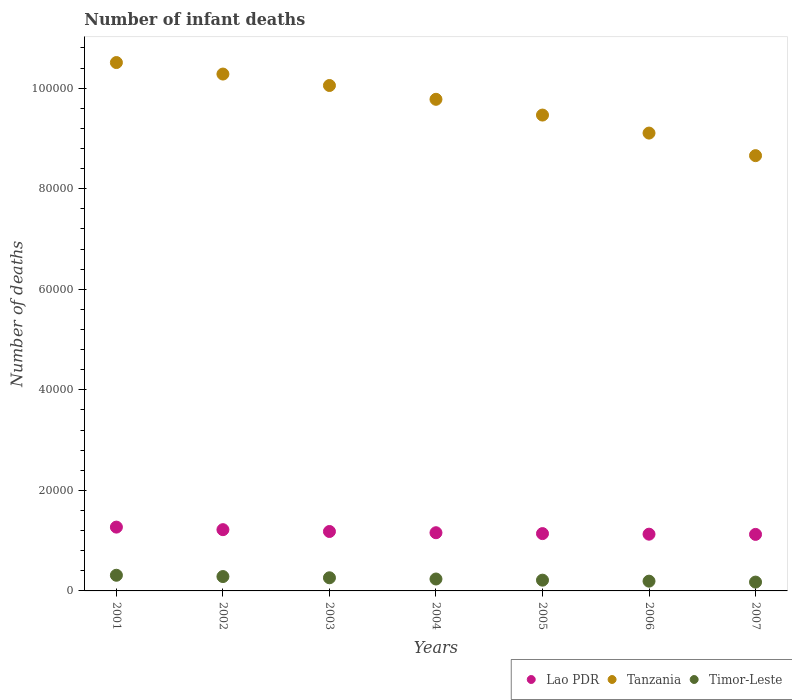What is the number of infant deaths in Timor-Leste in 2001?
Provide a short and direct response. 3116. Across all years, what is the maximum number of infant deaths in Timor-Leste?
Your response must be concise. 3116. Across all years, what is the minimum number of infant deaths in Timor-Leste?
Provide a short and direct response. 1757. What is the total number of infant deaths in Lao PDR in the graph?
Provide a short and direct response. 8.22e+04. What is the difference between the number of infant deaths in Timor-Leste in 2004 and that in 2006?
Give a very brief answer. 427. What is the difference between the number of infant deaths in Timor-Leste in 2003 and the number of infant deaths in Lao PDR in 2005?
Your response must be concise. -8790. What is the average number of infant deaths in Tanzania per year?
Keep it short and to the point. 9.69e+04. In the year 2002, what is the difference between the number of infant deaths in Lao PDR and number of infant deaths in Tanzania?
Give a very brief answer. -9.06e+04. What is the ratio of the number of infant deaths in Timor-Leste in 2002 to that in 2006?
Offer a terse response. 1.47. Is the number of infant deaths in Tanzania in 2002 less than that in 2005?
Offer a very short reply. No. What is the difference between the highest and the second highest number of infant deaths in Timor-Leste?
Keep it short and to the point. 259. What is the difference between the highest and the lowest number of infant deaths in Tanzania?
Ensure brevity in your answer.  1.85e+04. How many years are there in the graph?
Your answer should be very brief. 7. Are the values on the major ticks of Y-axis written in scientific E-notation?
Offer a terse response. No. Does the graph contain any zero values?
Make the answer very short. No. Does the graph contain grids?
Give a very brief answer. No. Where does the legend appear in the graph?
Your answer should be very brief. Bottom right. What is the title of the graph?
Your response must be concise. Number of infant deaths. What is the label or title of the X-axis?
Give a very brief answer. Years. What is the label or title of the Y-axis?
Offer a terse response. Number of deaths. What is the Number of deaths in Lao PDR in 2001?
Offer a very short reply. 1.27e+04. What is the Number of deaths of Tanzania in 2001?
Your answer should be very brief. 1.05e+05. What is the Number of deaths of Timor-Leste in 2001?
Give a very brief answer. 3116. What is the Number of deaths in Lao PDR in 2002?
Provide a short and direct response. 1.22e+04. What is the Number of deaths in Tanzania in 2002?
Ensure brevity in your answer.  1.03e+05. What is the Number of deaths of Timor-Leste in 2002?
Your response must be concise. 2857. What is the Number of deaths in Lao PDR in 2003?
Make the answer very short. 1.18e+04. What is the Number of deaths in Tanzania in 2003?
Your answer should be compact. 1.01e+05. What is the Number of deaths of Timor-Leste in 2003?
Your response must be concise. 2612. What is the Number of deaths in Lao PDR in 2004?
Your answer should be compact. 1.16e+04. What is the Number of deaths of Tanzania in 2004?
Give a very brief answer. 9.78e+04. What is the Number of deaths of Timor-Leste in 2004?
Keep it short and to the point. 2369. What is the Number of deaths of Lao PDR in 2005?
Offer a terse response. 1.14e+04. What is the Number of deaths in Tanzania in 2005?
Offer a terse response. 9.46e+04. What is the Number of deaths of Timor-Leste in 2005?
Your answer should be very brief. 2140. What is the Number of deaths of Lao PDR in 2006?
Your response must be concise. 1.13e+04. What is the Number of deaths of Tanzania in 2006?
Provide a short and direct response. 9.11e+04. What is the Number of deaths in Timor-Leste in 2006?
Offer a very short reply. 1942. What is the Number of deaths of Lao PDR in 2007?
Your answer should be compact. 1.12e+04. What is the Number of deaths of Tanzania in 2007?
Ensure brevity in your answer.  8.66e+04. What is the Number of deaths of Timor-Leste in 2007?
Your answer should be compact. 1757. Across all years, what is the maximum Number of deaths in Lao PDR?
Ensure brevity in your answer.  1.27e+04. Across all years, what is the maximum Number of deaths in Tanzania?
Offer a terse response. 1.05e+05. Across all years, what is the maximum Number of deaths in Timor-Leste?
Your answer should be compact. 3116. Across all years, what is the minimum Number of deaths of Lao PDR?
Ensure brevity in your answer.  1.12e+04. Across all years, what is the minimum Number of deaths of Tanzania?
Your response must be concise. 8.66e+04. Across all years, what is the minimum Number of deaths in Timor-Leste?
Offer a terse response. 1757. What is the total Number of deaths in Lao PDR in the graph?
Ensure brevity in your answer.  8.22e+04. What is the total Number of deaths in Tanzania in the graph?
Your response must be concise. 6.79e+05. What is the total Number of deaths in Timor-Leste in the graph?
Offer a very short reply. 1.68e+04. What is the difference between the Number of deaths in Lao PDR in 2001 and that in 2002?
Your answer should be very brief. 508. What is the difference between the Number of deaths in Tanzania in 2001 and that in 2002?
Provide a short and direct response. 2289. What is the difference between the Number of deaths in Timor-Leste in 2001 and that in 2002?
Your answer should be compact. 259. What is the difference between the Number of deaths in Lao PDR in 2001 and that in 2003?
Make the answer very short. 871. What is the difference between the Number of deaths of Tanzania in 2001 and that in 2003?
Offer a very short reply. 4564. What is the difference between the Number of deaths of Timor-Leste in 2001 and that in 2003?
Your answer should be very brief. 504. What is the difference between the Number of deaths of Lao PDR in 2001 and that in 2004?
Provide a succinct answer. 1116. What is the difference between the Number of deaths of Tanzania in 2001 and that in 2004?
Make the answer very short. 7311. What is the difference between the Number of deaths in Timor-Leste in 2001 and that in 2004?
Provide a succinct answer. 747. What is the difference between the Number of deaths in Lao PDR in 2001 and that in 2005?
Your answer should be very brief. 1290. What is the difference between the Number of deaths of Tanzania in 2001 and that in 2005?
Make the answer very short. 1.04e+04. What is the difference between the Number of deaths of Timor-Leste in 2001 and that in 2005?
Offer a very short reply. 976. What is the difference between the Number of deaths in Lao PDR in 2001 and that in 2006?
Give a very brief answer. 1406. What is the difference between the Number of deaths in Tanzania in 2001 and that in 2006?
Your response must be concise. 1.40e+04. What is the difference between the Number of deaths of Timor-Leste in 2001 and that in 2006?
Your answer should be compact. 1174. What is the difference between the Number of deaths of Lao PDR in 2001 and that in 2007?
Provide a succinct answer. 1448. What is the difference between the Number of deaths in Tanzania in 2001 and that in 2007?
Your answer should be very brief. 1.85e+04. What is the difference between the Number of deaths of Timor-Leste in 2001 and that in 2007?
Offer a very short reply. 1359. What is the difference between the Number of deaths in Lao PDR in 2002 and that in 2003?
Ensure brevity in your answer.  363. What is the difference between the Number of deaths in Tanzania in 2002 and that in 2003?
Your answer should be compact. 2275. What is the difference between the Number of deaths in Timor-Leste in 2002 and that in 2003?
Ensure brevity in your answer.  245. What is the difference between the Number of deaths in Lao PDR in 2002 and that in 2004?
Make the answer very short. 608. What is the difference between the Number of deaths in Tanzania in 2002 and that in 2004?
Give a very brief answer. 5022. What is the difference between the Number of deaths in Timor-Leste in 2002 and that in 2004?
Ensure brevity in your answer.  488. What is the difference between the Number of deaths in Lao PDR in 2002 and that in 2005?
Provide a short and direct response. 782. What is the difference between the Number of deaths of Tanzania in 2002 and that in 2005?
Your answer should be compact. 8156. What is the difference between the Number of deaths of Timor-Leste in 2002 and that in 2005?
Provide a short and direct response. 717. What is the difference between the Number of deaths in Lao PDR in 2002 and that in 2006?
Offer a terse response. 898. What is the difference between the Number of deaths in Tanzania in 2002 and that in 2006?
Give a very brief answer. 1.17e+04. What is the difference between the Number of deaths in Timor-Leste in 2002 and that in 2006?
Your response must be concise. 915. What is the difference between the Number of deaths in Lao PDR in 2002 and that in 2007?
Provide a succinct answer. 940. What is the difference between the Number of deaths of Tanzania in 2002 and that in 2007?
Offer a very short reply. 1.62e+04. What is the difference between the Number of deaths in Timor-Leste in 2002 and that in 2007?
Provide a succinct answer. 1100. What is the difference between the Number of deaths in Lao PDR in 2003 and that in 2004?
Your response must be concise. 245. What is the difference between the Number of deaths in Tanzania in 2003 and that in 2004?
Your answer should be compact. 2747. What is the difference between the Number of deaths in Timor-Leste in 2003 and that in 2004?
Ensure brevity in your answer.  243. What is the difference between the Number of deaths in Lao PDR in 2003 and that in 2005?
Make the answer very short. 419. What is the difference between the Number of deaths in Tanzania in 2003 and that in 2005?
Provide a short and direct response. 5881. What is the difference between the Number of deaths of Timor-Leste in 2003 and that in 2005?
Offer a very short reply. 472. What is the difference between the Number of deaths in Lao PDR in 2003 and that in 2006?
Keep it short and to the point. 535. What is the difference between the Number of deaths of Tanzania in 2003 and that in 2006?
Make the answer very short. 9465. What is the difference between the Number of deaths of Timor-Leste in 2003 and that in 2006?
Your response must be concise. 670. What is the difference between the Number of deaths of Lao PDR in 2003 and that in 2007?
Your answer should be compact. 577. What is the difference between the Number of deaths of Tanzania in 2003 and that in 2007?
Provide a short and direct response. 1.40e+04. What is the difference between the Number of deaths of Timor-Leste in 2003 and that in 2007?
Your answer should be compact. 855. What is the difference between the Number of deaths of Lao PDR in 2004 and that in 2005?
Offer a terse response. 174. What is the difference between the Number of deaths in Tanzania in 2004 and that in 2005?
Your response must be concise. 3134. What is the difference between the Number of deaths in Timor-Leste in 2004 and that in 2005?
Your answer should be very brief. 229. What is the difference between the Number of deaths in Lao PDR in 2004 and that in 2006?
Give a very brief answer. 290. What is the difference between the Number of deaths in Tanzania in 2004 and that in 2006?
Your answer should be compact. 6718. What is the difference between the Number of deaths in Timor-Leste in 2004 and that in 2006?
Provide a succinct answer. 427. What is the difference between the Number of deaths in Lao PDR in 2004 and that in 2007?
Offer a terse response. 332. What is the difference between the Number of deaths in Tanzania in 2004 and that in 2007?
Your response must be concise. 1.12e+04. What is the difference between the Number of deaths in Timor-Leste in 2004 and that in 2007?
Make the answer very short. 612. What is the difference between the Number of deaths of Lao PDR in 2005 and that in 2006?
Ensure brevity in your answer.  116. What is the difference between the Number of deaths of Tanzania in 2005 and that in 2006?
Your answer should be compact. 3584. What is the difference between the Number of deaths in Timor-Leste in 2005 and that in 2006?
Give a very brief answer. 198. What is the difference between the Number of deaths in Lao PDR in 2005 and that in 2007?
Keep it short and to the point. 158. What is the difference between the Number of deaths of Tanzania in 2005 and that in 2007?
Your response must be concise. 8071. What is the difference between the Number of deaths of Timor-Leste in 2005 and that in 2007?
Your answer should be compact. 383. What is the difference between the Number of deaths in Tanzania in 2006 and that in 2007?
Provide a succinct answer. 4487. What is the difference between the Number of deaths in Timor-Leste in 2006 and that in 2007?
Ensure brevity in your answer.  185. What is the difference between the Number of deaths of Lao PDR in 2001 and the Number of deaths of Tanzania in 2002?
Offer a very short reply. -9.01e+04. What is the difference between the Number of deaths of Lao PDR in 2001 and the Number of deaths of Timor-Leste in 2002?
Your answer should be very brief. 9835. What is the difference between the Number of deaths of Tanzania in 2001 and the Number of deaths of Timor-Leste in 2002?
Ensure brevity in your answer.  1.02e+05. What is the difference between the Number of deaths of Lao PDR in 2001 and the Number of deaths of Tanzania in 2003?
Provide a short and direct response. -8.78e+04. What is the difference between the Number of deaths in Lao PDR in 2001 and the Number of deaths in Timor-Leste in 2003?
Give a very brief answer. 1.01e+04. What is the difference between the Number of deaths in Tanzania in 2001 and the Number of deaths in Timor-Leste in 2003?
Ensure brevity in your answer.  1.02e+05. What is the difference between the Number of deaths of Lao PDR in 2001 and the Number of deaths of Tanzania in 2004?
Ensure brevity in your answer.  -8.51e+04. What is the difference between the Number of deaths in Lao PDR in 2001 and the Number of deaths in Timor-Leste in 2004?
Make the answer very short. 1.03e+04. What is the difference between the Number of deaths of Tanzania in 2001 and the Number of deaths of Timor-Leste in 2004?
Ensure brevity in your answer.  1.03e+05. What is the difference between the Number of deaths in Lao PDR in 2001 and the Number of deaths in Tanzania in 2005?
Your answer should be compact. -8.20e+04. What is the difference between the Number of deaths of Lao PDR in 2001 and the Number of deaths of Timor-Leste in 2005?
Your response must be concise. 1.06e+04. What is the difference between the Number of deaths in Tanzania in 2001 and the Number of deaths in Timor-Leste in 2005?
Provide a succinct answer. 1.03e+05. What is the difference between the Number of deaths in Lao PDR in 2001 and the Number of deaths in Tanzania in 2006?
Offer a very short reply. -7.84e+04. What is the difference between the Number of deaths of Lao PDR in 2001 and the Number of deaths of Timor-Leste in 2006?
Offer a terse response. 1.08e+04. What is the difference between the Number of deaths of Tanzania in 2001 and the Number of deaths of Timor-Leste in 2006?
Offer a very short reply. 1.03e+05. What is the difference between the Number of deaths of Lao PDR in 2001 and the Number of deaths of Tanzania in 2007?
Your answer should be very brief. -7.39e+04. What is the difference between the Number of deaths of Lao PDR in 2001 and the Number of deaths of Timor-Leste in 2007?
Offer a very short reply. 1.09e+04. What is the difference between the Number of deaths in Tanzania in 2001 and the Number of deaths in Timor-Leste in 2007?
Provide a succinct answer. 1.03e+05. What is the difference between the Number of deaths of Lao PDR in 2002 and the Number of deaths of Tanzania in 2003?
Your response must be concise. -8.83e+04. What is the difference between the Number of deaths in Lao PDR in 2002 and the Number of deaths in Timor-Leste in 2003?
Offer a terse response. 9572. What is the difference between the Number of deaths of Tanzania in 2002 and the Number of deaths of Timor-Leste in 2003?
Ensure brevity in your answer.  1.00e+05. What is the difference between the Number of deaths in Lao PDR in 2002 and the Number of deaths in Tanzania in 2004?
Your answer should be very brief. -8.56e+04. What is the difference between the Number of deaths in Lao PDR in 2002 and the Number of deaths in Timor-Leste in 2004?
Keep it short and to the point. 9815. What is the difference between the Number of deaths of Tanzania in 2002 and the Number of deaths of Timor-Leste in 2004?
Provide a short and direct response. 1.00e+05. What is the difference between the Number of deaths of Lao PDR in 2002 and the Number of deaths of Tanzania in 2005?
Give a very brief answer. -8.25e+04. What is the difference between the Number of deaths in Lao PDR in 2002 and the Number of deaths in Timor-Leste in 2005?
Offer a terse response. 1.00e+04. What is the difference between the Number of deaths in Tanzania in 2002 and the Number of deaths in Timor-Leste in 2005?
Offer a very short reply. 1.01e+05. What is the difference between the Number of deaths of Lao PDR in 2002 and the Number of deaths of Tanzania in 2006?
Keep it short and to the point. -7.89e+04. What is the difference between the Number of deaths in Lao PDR in 2002 and the Number of deaths in Timor-Leste in 2006?
Your answer should be very brief. 1.02e+04. What is the difference between the Number of deaths of Tanzania in 2002 and the Number of deaths of Timor-Leste in 2006?
Your answer should be very brief. 1.01e+05. What is the difference between the Number of deaths in Lao PDR in 2002 and the Number of deaths in Tanzania in 2007?
Your answer should be compact. -7.44e+04. What is the difference between the Number of deaths of Lao PDR in 2002 and the Number of deaths of Timor-Leste in 2007?
Provide a short and direct response. 1.04e+04. What is the difference between the Number of deaths in Tanzania in 2002 and the Number of deaths in Timor-Leste in 2007?
Make the answer very short. 1.01e+05. What is the difference between the Number of deaths in Lao PDR in 2003 and the Number of deaths in Tanzania in 2004?
Provide a succinct answer. -8.60e+04. What is the difference between the Number of deaths in Lao PDR in 2003 and the Number of deaths in Timor-Leste in 2004?
Your answer should be very brief. 9452. What is the difference between the Number of deaths of Tanzania in 2003 and the Number of deaths of Timor-Leste in 2004?
Offer a terse response. 9.82e+04. What is the difference between the Number of deaths of Lao PDR in 2003 and the Number of deaths of Tanzania in 2005?
Your answer should be compact. -8.28e+04. What is the difference between the Number of deaths of Lao PDR in 2003 and the Number of deaths of Timor-Leste in 2005?
Your answer should be compact. 9681. What is the difference between the Number of deaths in Tanzania in 2003 and the Number of deaths in Timor-Leste in 2005?
Your answer should be very brief. 9.84e+04. What is the difference between the Number of deaths of Lao PDR in 2003 and the Number of deaths of Tanzania in 2006?
Offer a very short reply. -7.92e+04. What is the difference between the Number of deaths in Lao PDR in 2003 and the Number of deaths in Timor-Leste in 2006?
Offer a terse response. 9879. What is the difference between the Number of deaths in Tanzania in 2003 and the Number of deaths in Timor-Leste in 2006?
Offer a very short reply. 9.86e+04. What is the difference between the Number of deaths in Lao PDR in 2003 and the Number of deaths in Tanzania in 2007?
Your answer should be very brief. -7.48e+04. What is the difference between the Number of deaths in Lao PDR in 2003 and the Number of deaths in Timor-Leste in 2007?
Make the answer very short. 1.01e+04. What is the difference between the Number of deaths of Tanzania in 2003 and the Number of deaths of Timor-Leste in 2007?
Your answer should be compact. 9.88e+04. What is the difference between the Number of deaths of Lao PDR in 2004 and the Number of deaths of Tanzania in 2005?
Offer a very short reply. -8.31e+04. What is the difference between the Number of deaths of Lao PDR in 2004 and the Number of deaths of Timor-Leste in 2005?
Your response must be concise. 9436. What is the difference between the Number of deaths in Tanzania in 2004 and the Number of deaths in Timor-Leste in 2005?
Keep it short and to the point. 9.56e+04. What is the difference between the Number of deaths in Lao PDR in 2004 and the Number of deaths in Tanzania in 2006?
Keep it short and to the point. -7.95e+04. What is the difference between the Number of deaths of Lao PDR in 2004 and the Number of deaths of Timor-Leste in 2006?
Your answer should be very brief. 9634. What is the difference between the Number of deaths in Tanzania in 2004 and the Number of deaths in Timor-Leste in 2006?
Provide a short and direct response. 9.58e+04. What is the difference between the Number of deaths in Lao PDR in 2004 and the Number of deaths in Tanzania in 2007?
Ensure brevity in your answer.  -7.50e+04. What is the difference between the Number of deaths of Lao PDR in 2004 and the Number of deaths of Timor-Leste in 2007?
Your response must be concise. 9819. What is the difference between the Number of deaths of Tanzania in 2004 and the Number of deaths of Timor-Leste in 2007?
Your response must be concise. 9.60e+04. What is the difference between the Number of deaths of Lao PDR in 2005 and the Number of deaths of Tanzania in 2006?
Make the answer very short. -7.97e+04. What is the difference between the Number of deaths of Lao PDR in 2005 and the Number of deaths of Timor-Leste in 2006?
Ensure brevity in your answer.  9460. What is the difference between the Number of deaths in Tanzania in 2005 and the Number of deaths in Timor-Leste in 2006?
Give a very brief answer. 9.27e+04. What is the difference between the Number of deaths in Lao PDR in 2005 and the Number of deaths in Tanzania in 2007?
Provide a succinct answer. -7.52e+04. What is the difference between the Number of deaths in Lao PDR in 2005 and the Number of deaths in Timor-Leste in 2007?
Provide a short and direct response. 9645. What is the difference between the Number of deaths in Tanzania in 2005 and the Number of deaths in Timor-Leste in 2007?
Your answer should be compact. 9.29e+04. What is the difference between the Number of deaths of Lao PDR in 2006 and the Number of deaths of Tanzania in 2007?
Offer a terse response. -7.53e+04. What is the difference between the Number of deaths in Lao PDR in 2006 and the Number of deaths in Timor-Leste in 2007?
Your answer should be very brief. 9529. What is the difference between the Number of deaths of Tanzania in 2006 and the Number of deaths of Timor-Leste in 2007?
Your response must be concise. 8.93e+04. What is the average Number of deaths in Lao PDR per year?
Offer a terse response. 1.17e+04. What is the average Number of deaths in Tanzania per year?
Ensure brevity in your answer.  9.69e+04. What is the average Number of deaths in Timor-Leste per year?
Give a very brief answer. 2399. In the year 2001, what is the difference between the Number of deaths in Lao PDR and Number of deaths in Tanzania?
Make the answer very short. -9.24e+04. In the year 2001, what is the difference between the Number of deaths of Lao PDR and Number of deaths of Timor-Leste?
Offer a terse response. 9576. In the year 2001, what is the difference between the Number of deaths in Tanzania and Number of deaths in Timor-Leste?
Keep it short and to the point. 1.02e+05. In the year 2002, what is the difference between the Number of deaths in Lao PDR and Number of deaths in Tanzania?
Keep it short and to the point. -9.06e+04. In the year 2002, what is the difference between the Number of deaths in Lao PDR and Number of deaths in Timor-Leste?
Your answer should be compact. 9327. In the year 2002, what is the difference between the Number of deaths of Tanzania and Number of deaths of Timor-Leste?
Offer a terse response. 9.99e+04. In the year 2003, what is the difference between the Number of deaths in Lao PDR and Number of deaths in Tanzania?
Give a very brief answer. -8.87e+04. In the year 2003, what is the difference between the Number of deaths of Lao PDR and Number of deaths of Timor-Leste?
Keep it short and to the point. 9209. In the year 2003, what is the difference between the Number of deaths of Tanzania and Number of deaths of Timor-Leste?
Keep it short and to the point. 9.79e+04. In the year 2004, what is the difference between the Number of deaths of Lao PDR and Number of deaths of Tanzania?
Make the answer very short. -8.62e+04. In the year 2004, what is the difference between the Number of deaths of Lao PDR and Number of deaths of Timor-Leste?
Make the answer very short. 9207. In the year 2004, what is the difference between the Number of deaths of Tanzania and Number of deaths of Timor-Leste?
Your response must be concise. 9.54e+04. In the year 2005, what is the difference between the Number of deaths of Lao PDR and Number of deaths of Tanzania?
Your answer should be compact. -8.32e+04. In the year 2005, what is the difference between the Number of deaths of Lao PDR and Number of deaths of Timor-Leste?
Offer a terse response. 9262. In the year 2005, what is the difference between the Number of deaths of Tanzania and Number of deaths of Timor-Leste?
Offer a very short reply. 9.25e+04. In the year 2006, what is the difference between the Number of deaths of Lao PDR and Number of deaths of Tanzania?
Offer a terse response. -7.98e+04. In the year 2006, what is the difference between the Number of deaths of Lao PDR and Number of deaths of Timor-Leste?
Your response must be concise. 9344. In the year 2006, what is the difference between the Number of deaths in Tanzania and Number of deaths in Timor-Leste?
Offer a terse response. 8.91e+04. In the year 2007, what is the difference between the Number of deaths of Lao PDR and Number of deaths of Tanzania?
Make the answer very short. -7.53e+04. In the year 2007, what is the difference between the Number of deaths in Lao PDR and Number of deaths in Timor-Leste?
Offer a terse response. 9487. In the year 2007, what is the difference between the Number of deaths of Tanzania and Number of deaths of Timor-Leste?
Provide a succinct answer. 8.48e+04. What is the ratio of the Number of deaths of Lao PDR in 2001 to that in 2002?
Keep it short and to the point. 1.04. What is the ratio of the Number of deaths of Tanzania in 2001 to that in 2002?
Your answer should be compact. 1.02. What is the ratio of the Number of deaths of Timor-Leste in 2001 to that in 2002?
Ensure brevity in your answer.  1.09. What is the ratio of the Number of deaths of Lao PDR in 2001 to that in 2003?
Your answer should be compact. 1.07. What is the ratio of the Number of deaths of Tanzania in 2001 to that in 2003?
Ensure brevity in your answer.  1.05. What is the ratio of the Number of deaths in Timor-Leste in 2001 to that in 2003?
Provide a short and direct response. 1.19. What is the ratio of the Number of deaths of Lao PDR in 2001 to that in 2004?
Make the answer very short. 1.1. What is the ratio of the Number of deaths of Tanzania in 2001 to that in 2004?
Keep it short and to the point. 1.07. What is the ratio of the Number of deaths in Timor-Leste in 2001 to that in 2004?
Keep it short and to the point. 1.32. What is the ratio of the Number of deaths of Lao PDR in 2001 to that in 2005?
Make the answer very short. 1.11. What is the ratio of the Number of deaths in Tanzania in 2001 to that in 2005?
Offer a terse response. 1.11. What is the ratio of the Number of deaths in Timor-Leste in 2001 to that in 2005?
Ensure brevity in your answer.  1.46. What is the ratio of the Number of deaths in Lao PDR in 2001 to that in 2006?
Keep it short and to the point. 1.12. What is the ratio of the Number of deaths of Tanzania in 2001 to that in 2006?
Provide a short and direct response. 1.15. What is the ratio of the Number of deaths of Timor-Leste in 2001 to that in 2006?
Ensure brevity in your answer.  1.6. What is the ratio of the Number of deaths in Lao PDR in 2001 to that in 2007?
Keep it short and to the point. 1.13. What is the ratio of the Number of deaths in Tanzania in 2001 to that in 2007?
Provide a succinct answer. 1.21. What is the ratio of the Number of deaths of Timor-Leste in 2001 to that in 2007?
Make the answer very short. 1.77. What is the ratio of the Number of deaths of Lao PDR in 2002 to that in 2003?
Your response must be concise. 1.03. What is the ratio of the Number of deaths in Tanzania in 2002 to that in 2003?
Your answer should be compact. 1.02. What is the ratio of the Number of deaths of Timor-Leste in 2002 to that in 2003?
Provide a succinct answer. 1.09. What is the ratio of the Number of deaths in Lao PDR in 2002 to that in 2004?
Offer a terse response. 1.05. What is the ratio of the Number of deaths in Tanzania in 2002 to that in 2004?
Keep it short and to the point. 1.05. What is the ratio of the Number of deaths of Timor-Leste in 2002 to that in 2004?
Your answer should be very brief. 1.21. What is the ratio of the Number of deaths of Lao PDR in 2002 to that in 2005?
Your answer should be compact. 1.07. What is the ratio of the Number of deaths in Tanzania in 2002 to that in 2005?
Your answer should be very brief. 1.09. What is the ratio of the Number of deaths in Timor-Leste in 2002 to that in 2005?
Your answer should be compact. 1.33. What is the ratio of the Number of deaths in Lao PDR in 2002 to that in 2006?
Offer a very short reply. 1.08. What is the ratio of the Number of deaths in Tanzania in 2002 to that in 2006?
Your answer should be compact. 1.13. What is the ratio of the Number of deaths in Timor-Leste in 2002 to that in 2006?
Ensure brevity in your answer.  1.47. What is the ratio of the Number of deaths in Lao PDR in 2002 to that in 2007?
Give a very brief answer. 1.08. What is the ratio of the Number of deaths of Tanzania in 2002 to that in 2007?
Your response must be concise. 1.19. What is the ratio of the Number of deaths in Timor-Leste in 2002 to that in 2007?
Offer a terse response. 1.63. What is the ratio of the Number of deaths in Lao PDR in 2003 to that in 2004?
Your response must be concise. 1.02. What is the ratio of the Number of deaths in Tanzania in 2003 to that in 2004?
Offer a very short reply. 1.03. What is the ratio of the Number of deaths in Timor-Leste in 2003 to that in 2004?
Offer a very short reply. 1.1. What is the ratio of the Number of deaths in Lao PDR in 2003 to that in 2005?
Your answer should be very brief. 1.04. What is the ratio of the Number of deaths of Tanzania in 2003 to that in 2005?
Your response must be concise. 1.06. What is the ratio of the Number of deaths in Timor-Leste in 2003 to that in 2005?
Your answer should be very brief. 1.22. What is the ratio of the Number of deaths of Lao PDR in 2003 to that in 2006?
Give a very brief answer. 1.05. What is the ratio of the Number of deaths of Tanzania in 2003 to that in 2006?
Your response must be concise. 1.1. What is the ratio of the Number of deaths of Timor-Leste in 2003 to that in 2006?
Ensure brevity in your answer.  1.34. What is the ratio of the Number of deaths in Lao PDR in 2003 to that in 2007?
Offer a terse response. 1.05. What is the ratio of the Number of deaths of Tanzania in 2003 to that in 2007?
Give a very brief answer. 1.16. What is the ratio of the Number of deaths in Timor-Leste in 2003 to that in 2007?
Your answer should be very brief. 1.49. What is the ratio of the Number of deaths in Lao PDR in 2004 to that in 2005?
Offer a terse response. 1.02. What is the ratio of the Number of deaths of Tanzania in 2004 to that in 2005?
Offer a terse response. 1.03. What is the ratio of the Number of deaths in Timor-Leste in 2004 to that in 2005?
Offer a terse response. 1.11. What is the ratio of the Number of deaths of Lao PDR in 2004 to that in 2006?
Ensure brevity in your answer.  1.03. What is the ratio of the Number of deaths of Tanzania in 2004 to that in 2006?
Ensure brevity in your answer.  1.07. What is the ratio of the Number of deaths in Timor-Leste in 2004 to that in 2006?
Your answer should be very brief. 1.22. What is the ratio of the Number of deaths of Lao PDR in 2004 to that in 2007?
Offer a very short reply. 1.03. What is the ratio of the Number of deaths of Tanzania in 2004 to that in 2007?
Your answer should be compact. 1.13. What is the ratio of the Number of deaths in Timor-Leste in 2004 to that in 2007?
Provide a short and direct response. 1.35. What is the ratio of the Number of deaths of Lao PDR in 2005 to that in 2006?
Your response must be concise. 1.01. What is the ratio of the Number of deaths in Tanzania in 2005 to that in 2006?
Offer a terse response. 1.04. What is the ratio of the Number of deaths of Timor-Leste in 2005 to that in 2006?
Provide a succinct answer. 1.1. What is the ratio of the Number of deaths of Lao PDR in 2005 to that in 2007?
Keep it short and to the point. 1.01. What is the ratio of the Number of deaths of Tanzania in 2005 to that in 2007?
Provide a short and direct response. 1.09. What is the ratio of the Number of deaths in Timor-Leste in 2005 to that in 2007?
Offer a terse response. 1.22. What is the ratio of the Number of deaths in Lao PDR in 2006 to that in 2007?
Give a very brief answer. 1. What is the ratio of the Number of deaths in Tanzania in 2006 to that in 2007?
Make the answer very short. 1.05. What is the ratio of the Number of deaths of Timor-Leste in 2006 to that in 2007?
Your answer should be very brief. 1.11. What is the difference between the highest and the second highest Number of deaths in Lao PDR?
Make the answer very short. 508. What is the difference between the highest and the second highest Number of deaths in Tanzania?
Provide a succinct answer. 2289. What is the difference between the highest and the second highest Number of deaths of Timor-Leste?
Your answer should be very brief. 259. What is the difference between the highest and the lowest Number of deaths of Lao PDR?
Your answer should be very brief. 1448. What is the difference between the highest and the lowest Number of deaths in Tanzania?
Provide a short and direct response. 1.85e+04. What is the difference between the highest and the lowest Number of deaths in Timor-Leste?
Keep it short and to the point. 1359. 